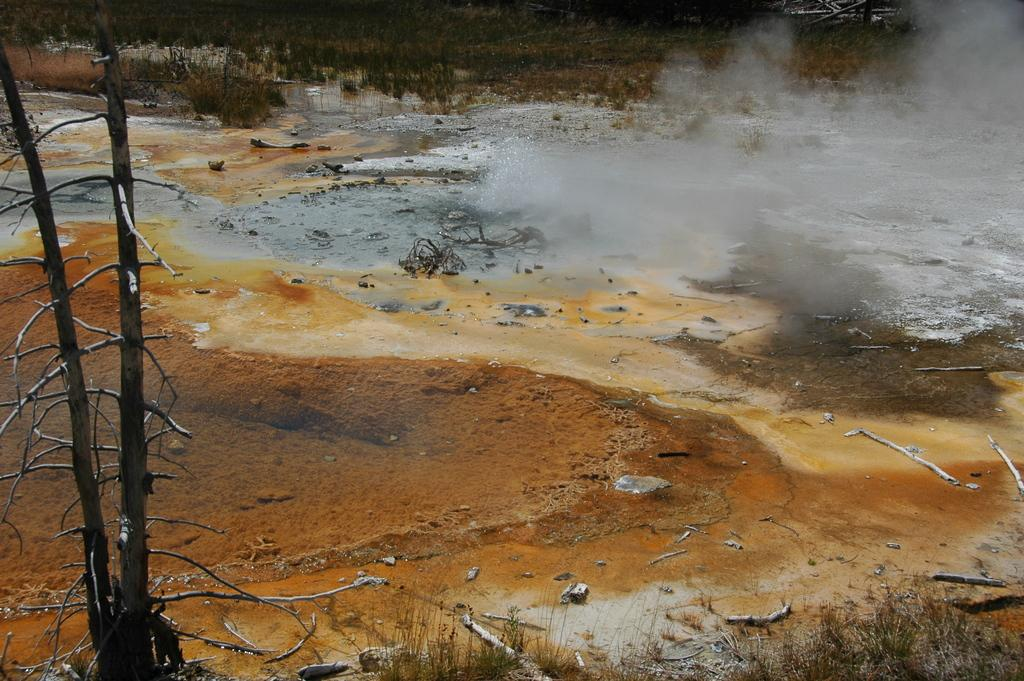What natural feature is present in the image? There is a hot spring in the image. What type of vegetation can be seen in the image? There are trees in the image. Are there any specific parts of the trees visible in the image? Yes, there are branches in the image. What type of dinner is being served in the image? There is no dinner present in the image; it features a hot spring and trees. What type of power source is visible in the image? There is no power source visible in the image; it features a hot spring, trees, and branches. 